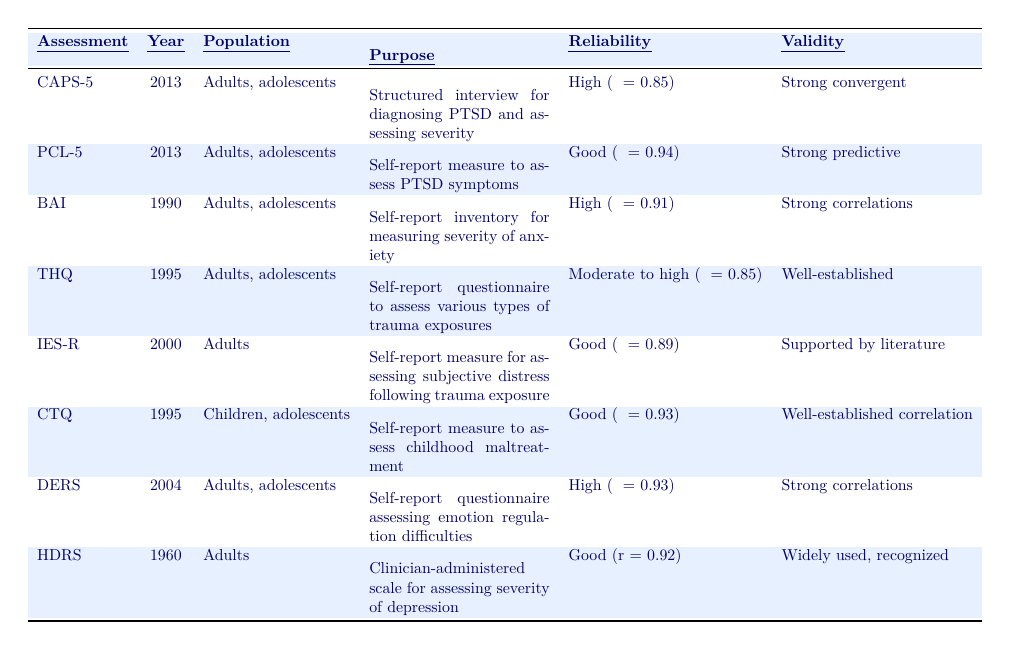What are the reliability scores for the CAPS-5? The reliability score for the CAPS-5 is listed in the table as "High internal consistency (α = 0.85)."
Answer: 0.85 Which assessment was introduced first, the BAI or the HDRS? The BAI was introduced in 1990, while the HDRS was introduced in 1960. Since 1960 is earlier, HDRS was introduced first.
Answer: HDRS Are all assessments in the table intended for adults? The CTQ is designed for children and adolescents, while the other assessments are for adults, adolescents, or both. Thus, not all assessments are solely for adults.
Answer: No What is the purpose of the PTSD Checklist for DSM-5 (PCL-5)? The purpose of the PCL-5, as stated in the table, is to serve as a self-report measure to assess PTSD symptoms.
Answer: Self-report measure to assess PTSD symptoms Which assessment has the highest reliability score? The PCL-5 has the highest reliability score of α = 0.94, compared to other assessments in the table.
Answer: PCL-5 What year were the THQ and CTQ assessments introduced? The THQ was introduced in 1995 and the CTQ was also introduced in 1995; they were introduced in the same year.
Answer: 1995 How many assessments in the table were introduced after the year 2000? The assessments introduced after 2000 include PCL-5, DERS, and IES-R, which totals to three.
Answer: 3 Is the reliability of the Hamilton Depression Rating Scale higher than that of the Difficulties in Emotion Regulation Scale? The HDRS has a reliability score of r = 0.92, while the DERS has a higher reliability score of α = 0.93. Therefore, HDRS does not have higher reliability.
Answer: No What is the target population for the Impact of Event Scale-Revised? The target population for the IES-R, according to the table, is adults.
Answer: Adults Compare the validity of the Childhood Trauma Questionnaire (CTQ) and the Trauma History Questionnaire (THQ). The CTQ has a well-established correlation with externalizing and internalizing problems, while the THQ has well-established historical and contextual validity. Both have strong validity but focus on different aspects of trauma.
Answer: Both have strong validity but differ in focus 